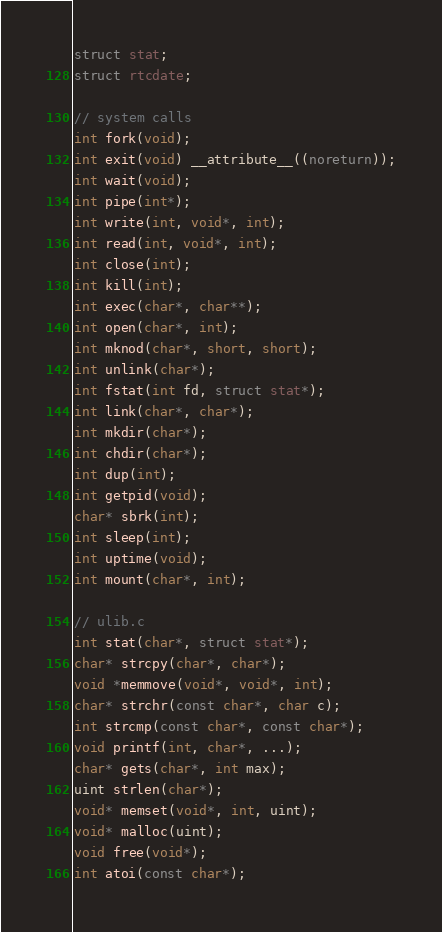<code> <loc_0><loc_0><loc_500><loc_500><_C_>struct stat;
struct rtcdate;

// system calls
int fork(void);
int exit(void) __attribute__((noreturn));
int wait(void);
int pipe(int*);
int write(int, void*, int);
int read(int, void*, int);
int close(int);
int kill(int);
int exec(char*, char**);
int open(char*, int);
int mknod(char*, short, short);
int unlink(char*);
int fstat(int fd, struct stat*);
int link(char*, char*);
int mkdir(char*);
int chdir(char*);
int dup(int);
int getpid(void);
char* sbrk(int);
int sleep(int);
int uptime(void);
int mount(char*, int);

// ulib.c
int stat(char*, struct stat*);
char* strcpy(char*, char*);
void *memmove(void*, void*, int);
char* strchr(const char*, char c);
int strcmp(const char*, const char*);
void printf(int, char*, ...);
char* gets(char*, int max);
uint strlen(char*);
void* memset(void*, int, uint);
void* malloc(uint);
void free(void*);
int atoi(const char*);
</code> 